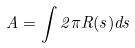Convert formula to latex. <formula><loc_0><loc_0><loc_500><loc_500>A = \int 2 \pi R ( s ) d s</formula> 